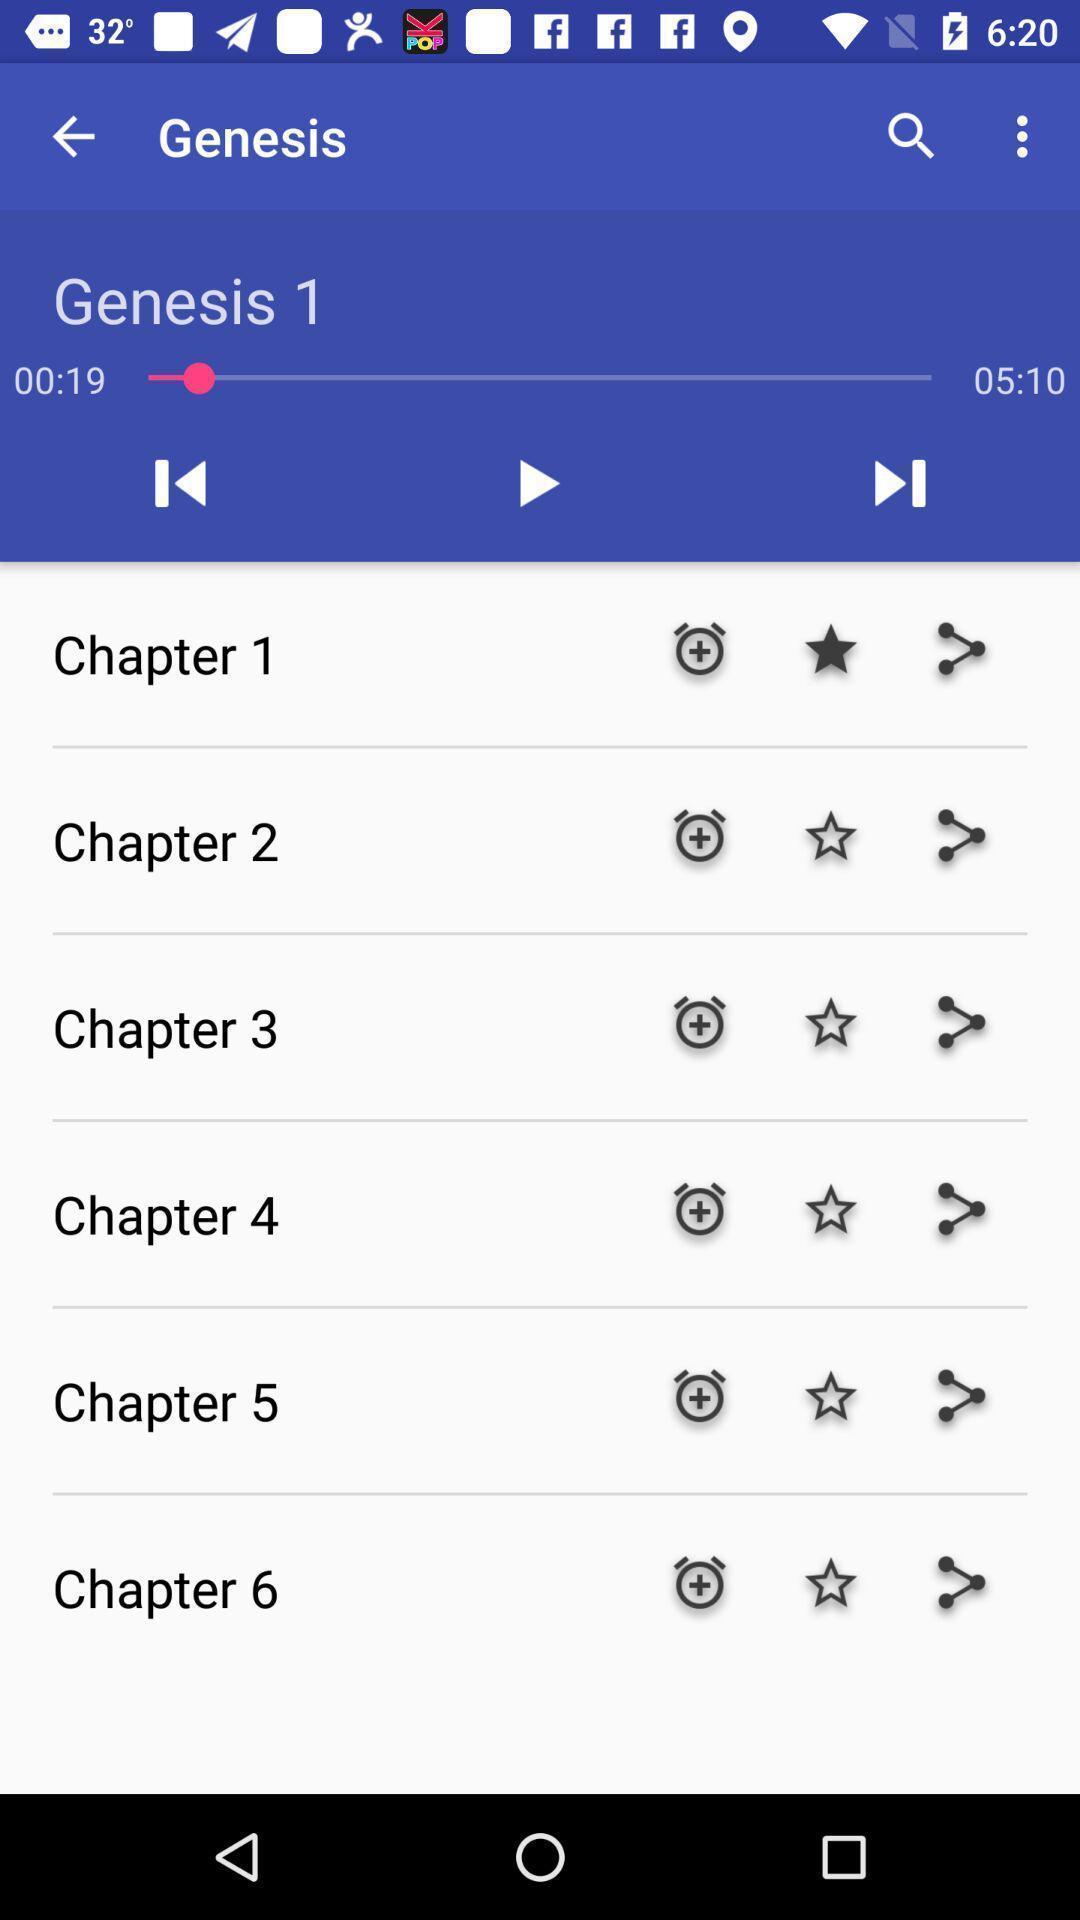Provide a textual representation of this image. Screen displaying different types of audios. 